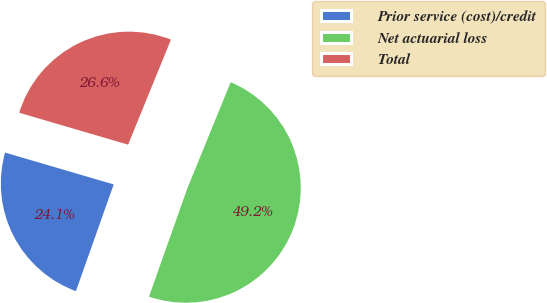<chart> <loc_0><loc_0><loc_500><loc_500><pie_chart><fcel>Prior service (cost)/credit<fcel>Net actuarial loss<fcel>Total<nl><fcel>24.12%<fcel>49.25%<fcel>26.63%<nl></chart> 